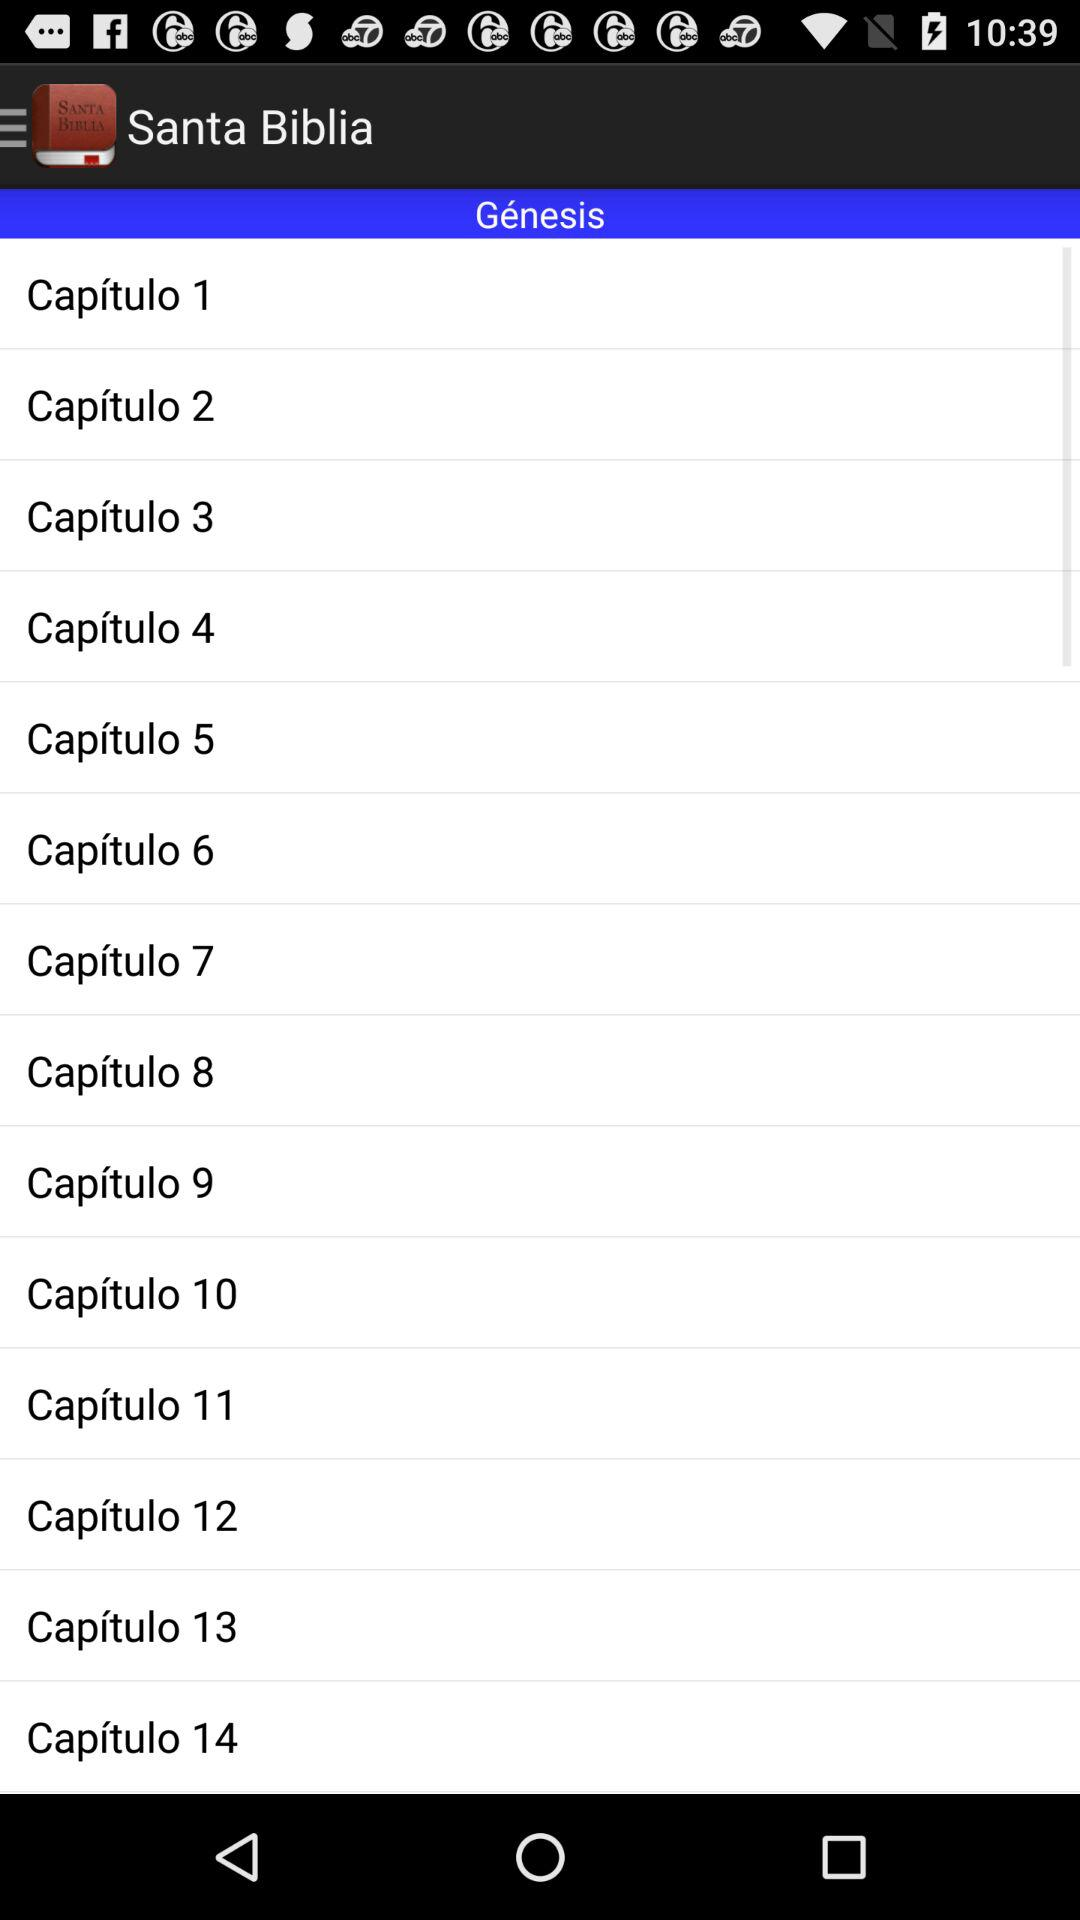How many chapters are there in the book of Genesis?
Answer the question using a single word or phrase. 14 